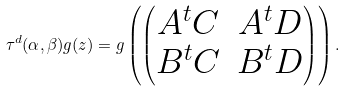Convert formula to latex. <formula><loc_0><loc_0><loc_500><loc_500>\tau ^ { d } ( \alpha , \beta ) g ( z ) = g \left ( \begin{pmatrix} A ^ { t } C & A ^ { t } D \\ B ^ { t } C & B ^ { t } D \end{pmatrix} \right ) .</formula> 